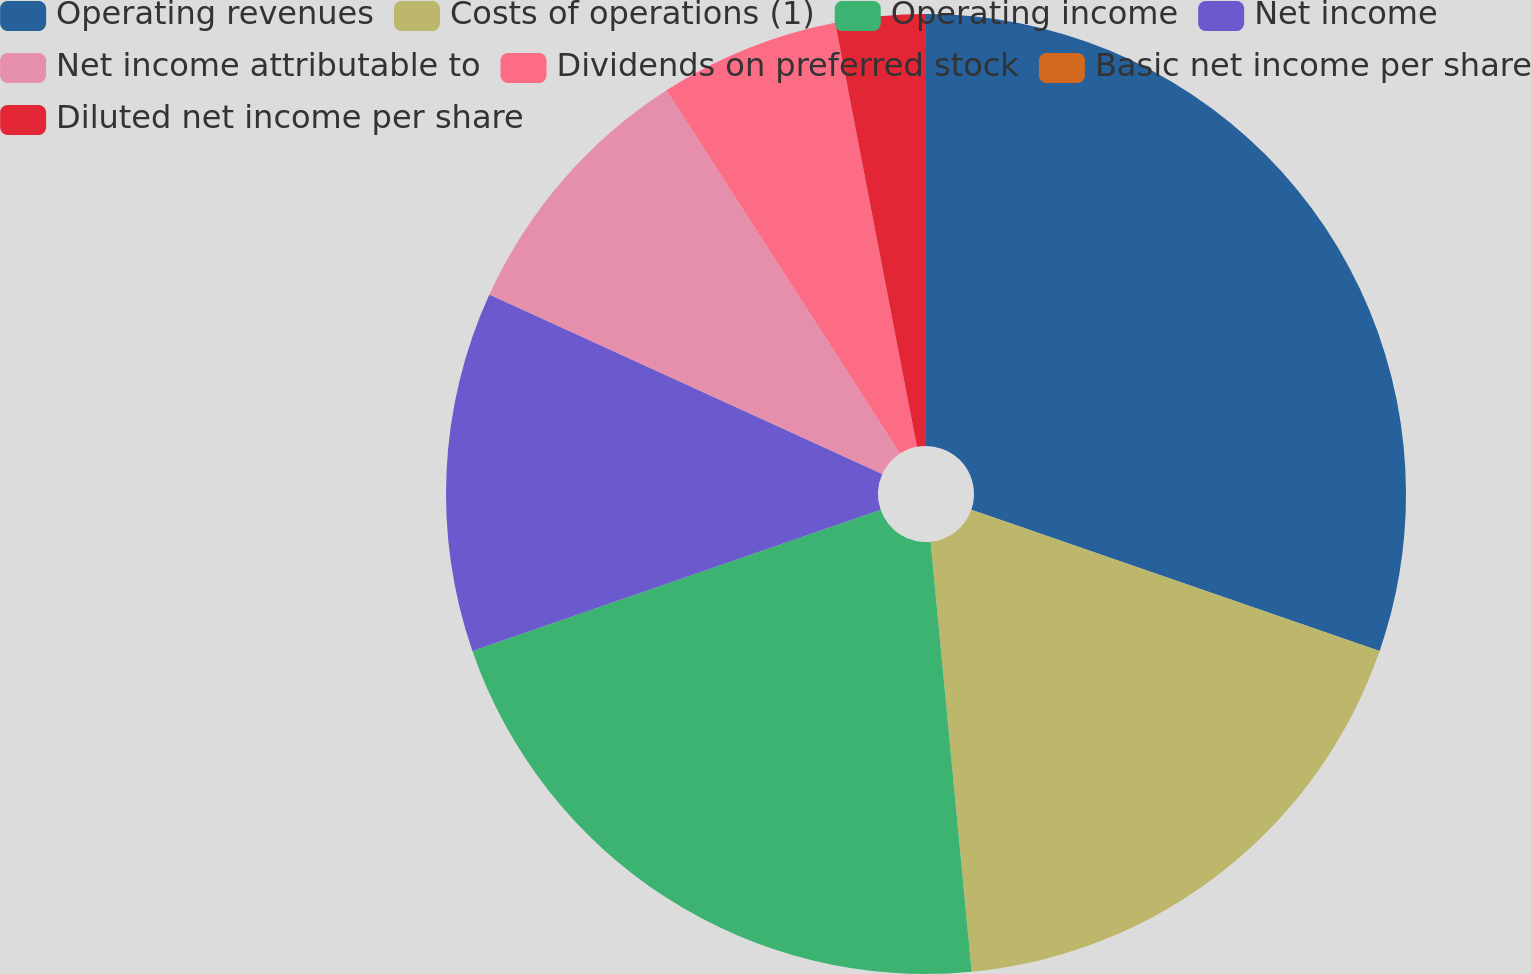<chart> <loc_0><loc_0><loc_500><loc_500><pie_chart><fcel>Operating revenues<fcel>Costs of operations (1)<fcel>Operating income<fcel>Net income<fcel>Net income attributable to<fcel>Dividends on preferred stock<fcel>Basic net income per share<fcel>Diluted net income per share<nl><fcel>30.3%<fcel>18.18%<fcel>21.21%<fcel>12.12%<fcel>9.09%<fcel>6.06%<fcel>0.0%<fcel>3.03%<nl></chart> 